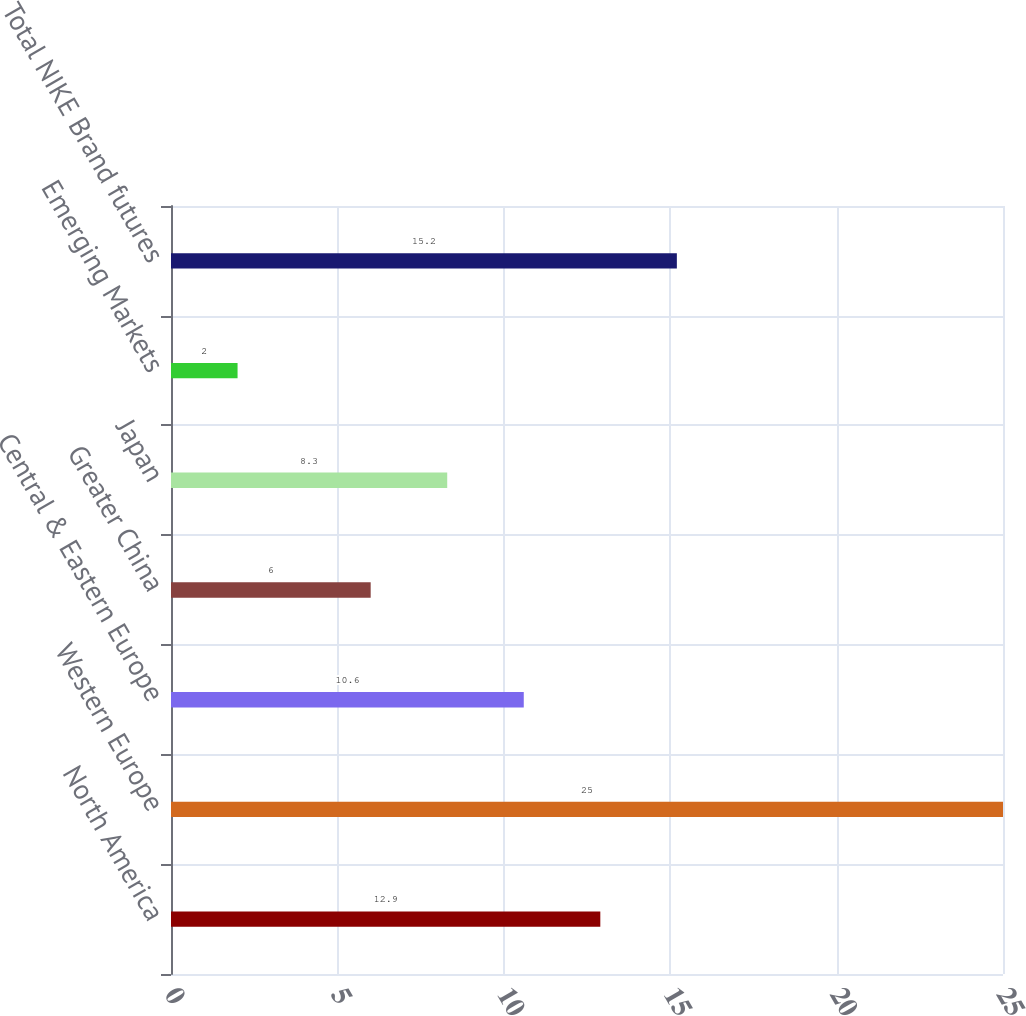Convert chart. <chart><loc_0><loc_0><loc_500><loc_500><bar_chart><fcel>North America<fcel>Western Europe<fcel>Central & Eastern Europe<fcel>Greater China<fcel>Japan<fcel>Emerging Markets<fcel>Total NIKE Brand futures<nl><fcel>12.9<fcel>25<fcel>10.6<fcel>6<fcel>8.3<fcel>2<fcel>15.2<nl></chart> 